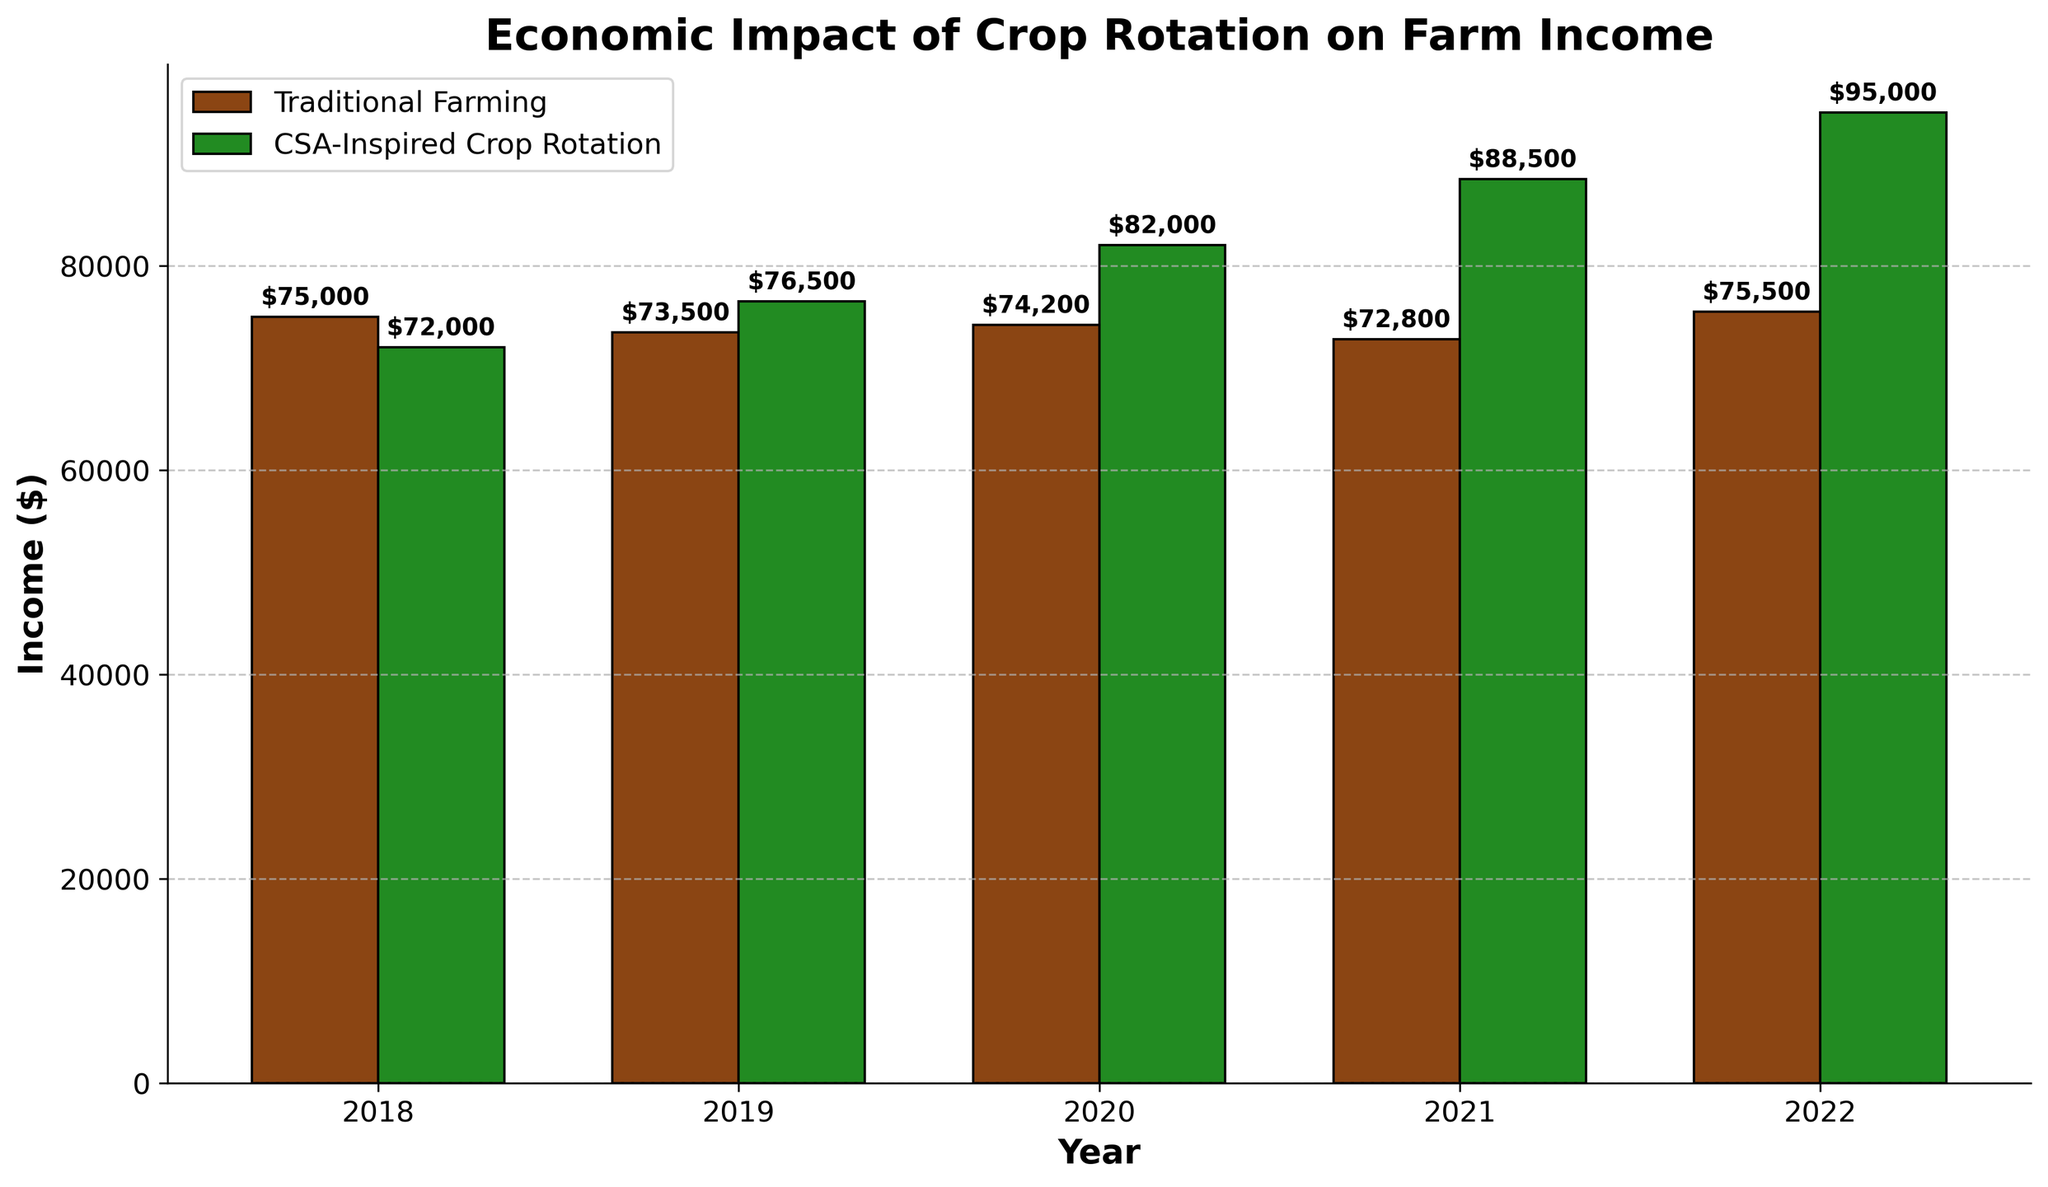How did farmers' incomes from CSA-Inspired Crop Rotation change from 2018 to 2022? To find this, we observe the heights of the green bars labeled for 2018 and 2022. In 2018, the income was $72,000, and in 2022, it was $95,000. The change is $95,000 - $72,000.
Answer: Increased by $23,000 Which year had the highest income for Traditional Farming? We need to look for the tallest brown bar among the years. The highest bar for Traditional Farming was in 2022 with an income of $75,500.
Answer: 2022 In which year did CSA-Inspired Crop Rotation first surpass Traditional Farming in income? Compare the green and brown bars for each year. The green bar surpasses the brown bar first in 2019, where the income was $76,500 for CSA-Inspired and $73,500 for Traditional.
Answer: 2019 What is the income difference between Traditional Farming and CSA-Inspired Crop Rotation in 2022? Check the 2022 bars: Traditional Farming income is $75,500 and CSA-Inspired Crop Rotation income is $95,000. The difference is $95,000 - $75,500.
Answer: $19,500 Calculate the average income for CSA-Inspired Crop Rotation over the five-year period. Sum the incomes for CSA-Inspired Crop Rotation from 2018 to 2022 ($72,000 + $76,500 + $82,000 + $88,500 + $95,000) and then divide by 5 to get the average. Average = ($72,000 + $76,500 + $82,000 + $88,500 + $95,000)/5 = $82,400.
Answer: $82,400 Was there any year where the income from Traditional Farming increased compared to the previous year? Compare year-on-year income for Traditional Farming: 2018 ($75,000) to 2019 ($73,500) is a decrease; 2019 to 2020 ($74,200) is an increase; 2020 to 2021 ($72,800) is a decrease; 2021 to 2022 ($75,500) is an increase. Therefore, it increased from 2019 to 2020 and from 2021 to 2022.
Answer: Yes What was the total income for Traditional Farming over the five years? Add the income for all five years: $75,000 + $73,500 + $74,200 + $72,800 + $75,500. Total = $75,000 + $73,500 + $74,200 + $72,800 + $75,500 = $370,000.
Answer: $370,000 Compare the income trends for Traditional Farming and CSA-Inspired Crop Rotation from 2018 to 2022. Traditional Farming shows slight fluctuations without a consistent trend, with its income slightly increasing or decreasing. On the other hand, CSA-Inspired Crop Rotation shows a consistent upward trend each year from $72,000 in 2018 to $95,000 in 2022.
Answer: CSA-Inspired Crop Rotation consistently increased while Traditional Farming fluctuated 